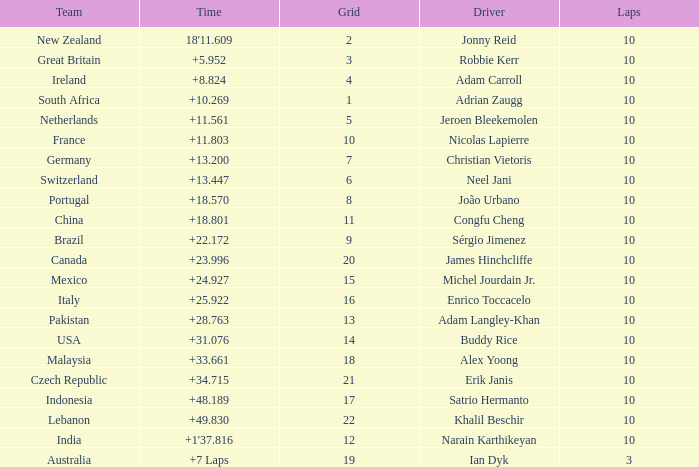What team had 10 Labs and the Driver was Alex Yoong? Malaysia. 